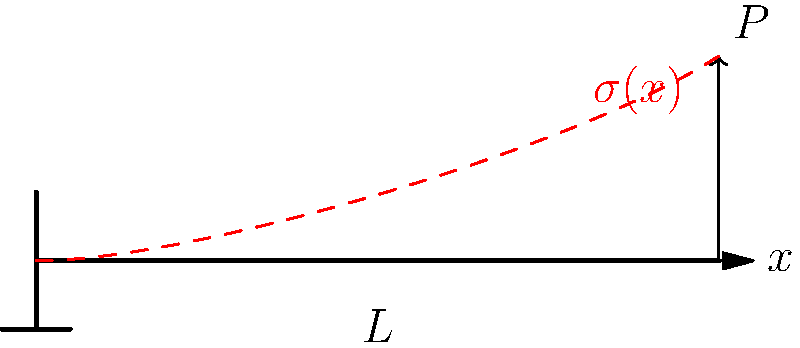A cantilever beam of length $L$ is subjected to a point load $P$ at its free end. Given that the beam has a rectangular cross-section with width $b$ and height $h$, derive an expression for the normal stress $\sigma(x)$ at a distance $x$ from the fixed end and at a distance $y$ from the neutral axis. How would you implement this calculation in a PHP function using the MVC pattern? To solve this problem, we'll follow these steps:

1. Determine the bending moment equation:
   The bending moment at any point $x$ along the beam is given by:
   $$M(x) = P(L-x)$$

2. Use the flexure formula to relate stress to the bending moment:
   $$\sigma = \frac{My}{I}$$
   where $I$ is the moment of inertia of the rectangular cross-section.

3. Calculate the moment of inertia for a rectangular cross-section:
   $$I = \frac{bh^3}{12}$$

4. Substitute the expressions for $M(x)$ and $I$ into the flexure formula:
   $$\sigma(x,y) = \frac{P(L-x)y}{\frac{bh^3}{12}}$$

5. Simplify the expression:
   $$\sigma(x,y) = \frac{12P(L-x)y}{bh^3}$$

To implement this calculation in PHP using the MVC pattern:

1. Model: Create a BeamStress class to handle the calculations.
```php
class BeamStress {
    private $P, $L, $b, $h;

    public function __construct($P, $L, $b, $h) {
        $this->P = $P;
        $this->L = $L;
        $this->b = $b;
        $this->h = $h;
    }

    public function calculateStress($x, $y) {
        return (12 * $this->P * ($this->L - $x) * $y) / ($this->b * pow($this->h, 3));
    }
}
```

2. Controller: Create a BeamStressController to handle user input and interact with the model.
```php
class BeamStressController {
    private $model;

    public function __construct(BeamStress $model) {
        $this->model = $model;
    }

    public function getStress($x, $y) {
        return $this->model->calculateStress($x, $y);
    }
}
```

3. View: Create a view to display the results.
```php
class BeamStressView {
    public function displayStress($stress) {
        echo "The normal stress at the given point is: " . number_format($stress, 2) . " Pa";
    }
}
```

4. Usage:
```php
$model = new BeamStress(1000, 2, 0.1, 0.2); // P=1000N, L=2m, b=0.1m, h=0.2m
$controller = new BeamStressController($model);
$view = new BeamStressView();

$x = 1; // 1m from fixed end
$y = 0.1; // 0.1m from neutral axis

$stress = $controller->getStress($x, $y);
$view->displayStress($stress);
```

This implementation follows the MVC pattern, separating the calculation logic (Model), user interaction (Controller), and result display (View).
Answer: $\sigma(x,y) = \frac{12P(L-x)y}{bh^3}$ 